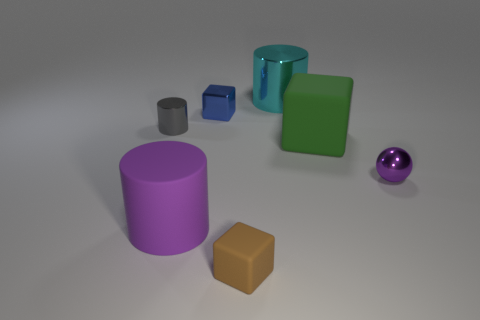How many other objects are there of the same color as the metallic sphere?
Your answer should be very brief. 1. There is a matte object that is the same shape as the tiny gray metal object; what color is it?
Make the answer very short. Purple. Is there anything else that has the same shape as the big green thing?
Offer a very short reply. Yes. What number of blocks are green things or small matte things?
Offer a terse response. 2. The small gray thing is what shape?
Give a very brief answer. Cylinder. There is a small metallic sphere; are there any tiny brown matte blocks behind it?
Give a very brief answer. No. Is the tiny gray cylinder made of the same material as the tiny cube in front of the small gray thing?
Your answer should be very brief. No. Is the shape of the big rubber object behind the ball the same as  the blue object?
Provide a succinct answer. Yes. How many gray cylinders have the same material as the big purple object?
Your response must be concise. 0. How many objects are either large things on the left side of the blue metallic cube or tiny gray cylinders?
Make the answer very short. 2. 